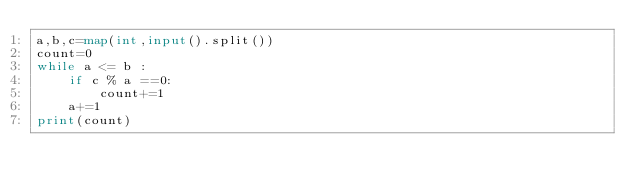Convert code to text. <code><loc_0><loc_0><loc_500><loc_500><_Python_>a,b,c=map(int,input().split())
count=0
while a <= b :
    if c % a ==0:
        count+=1
    a+=1
print(count)
    
</code> 